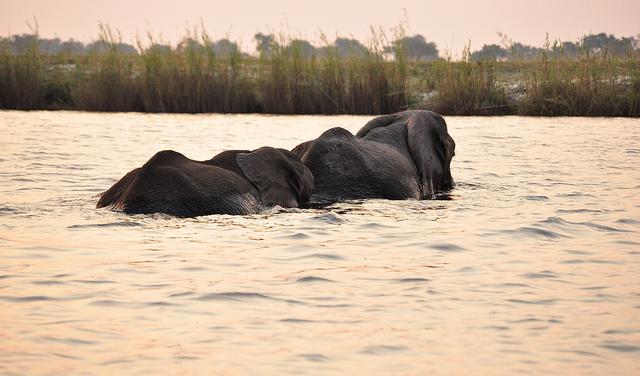What time of day is it?
Keep it brief. Evening. What is the animal in the water doing?
Give a very brief answer. Swimming. Is this water deep?
Concise answer only. Yes. 